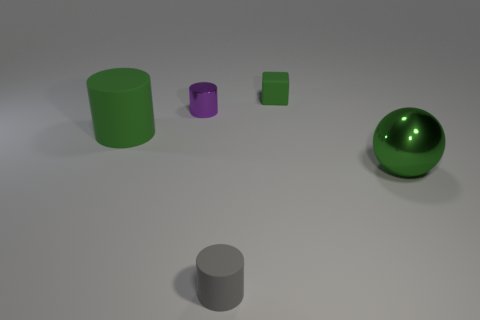Add 1 tiny objects. How many objects exist? 6 Subtract all cylinders. How many objects are left? 2 Subtract all small yellow matte things. Subtract all large matte things. How many objects are left? 4 Add 2 large green balls. How many large green balls are left? 3 Add 4 small objects. How many small objects exist? 7 Subtract 0 yellow cylinders. How many objects are left? 5 